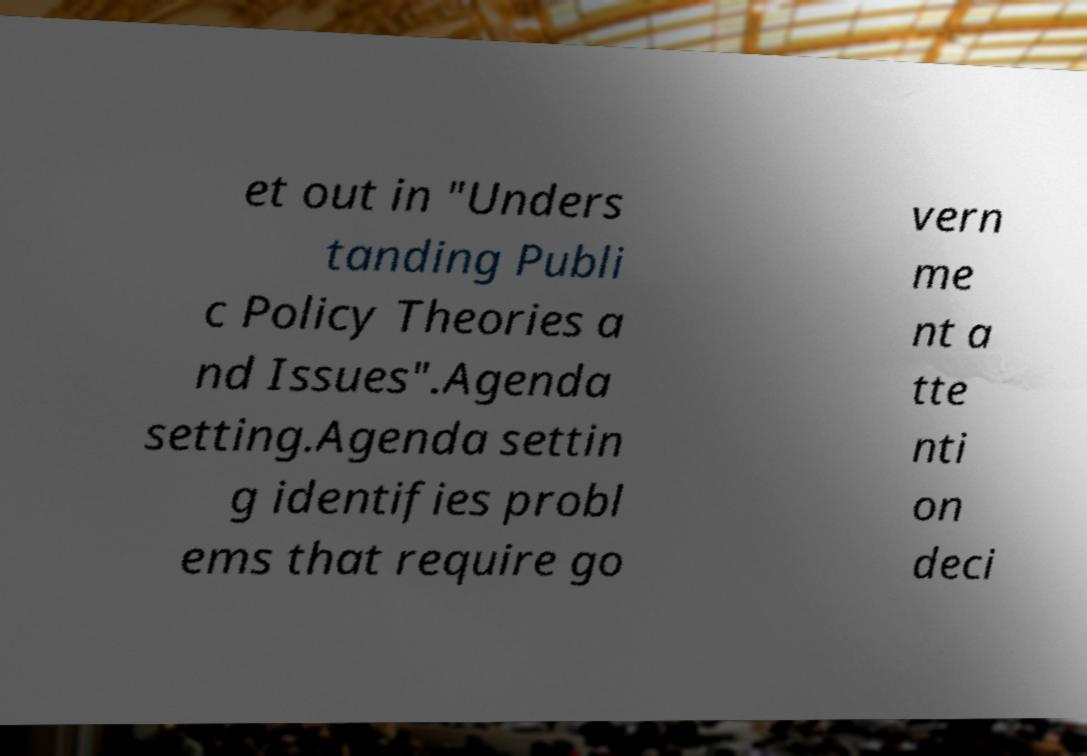Can you accurately transcribe the text from the provided image for me? et out in "Unders tanding Publi c Policy Theories a nd Issues".Agenda setting.Agenda settin g identifies probl ems that require go vern me nt a tte nti on deci 